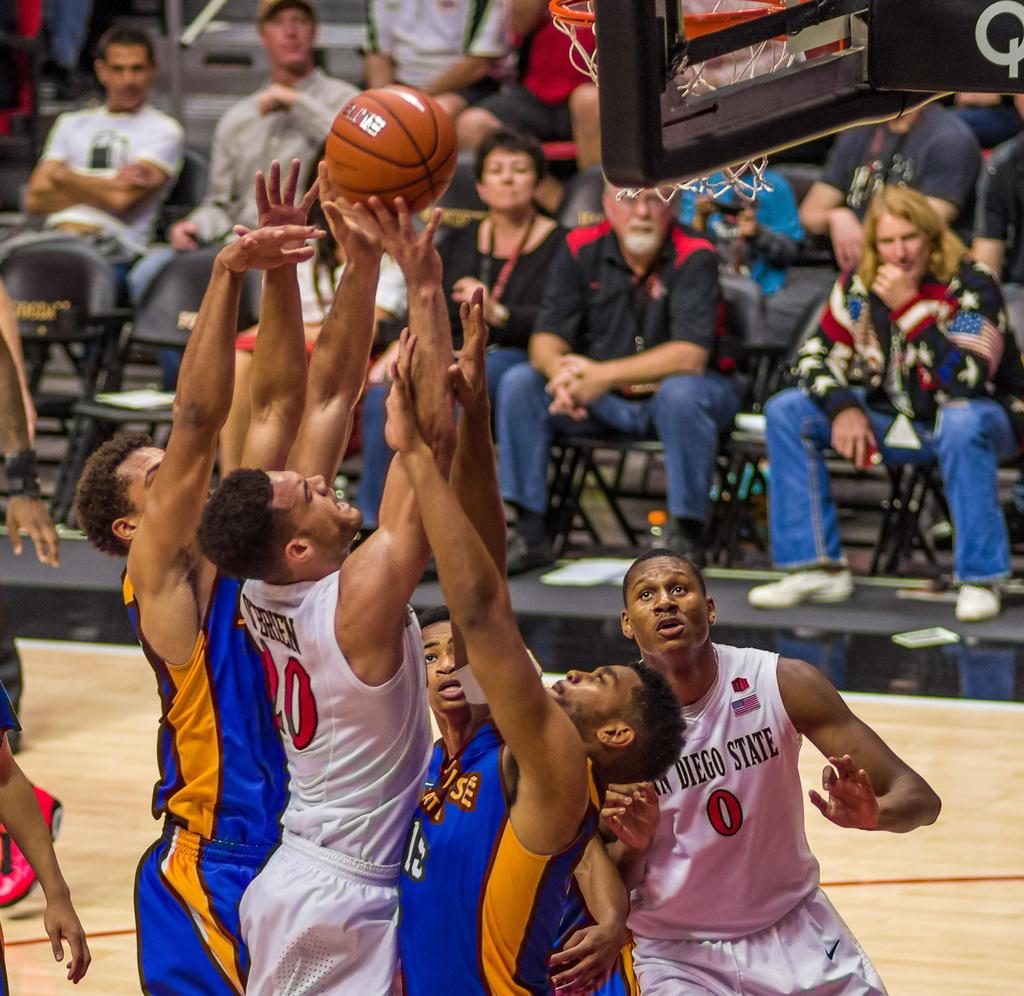What are the people in the image doing? Some people are playing basketball, and some people are sitting on chairs. Can you describe the activities of the people in the image? The people playing basketball are engaged in a physical activity, while the people sitting on chairs are likely resting or watching the game. How many different activities can be observed in the image? Two activities can be observed in the image: playing basketball and sitting on chairs. How many boys with heart-shaped balloons are present in the image? There are no boys with heart-shaped balloons present in the image; the image features people playing basketball and sitting on chairs. 